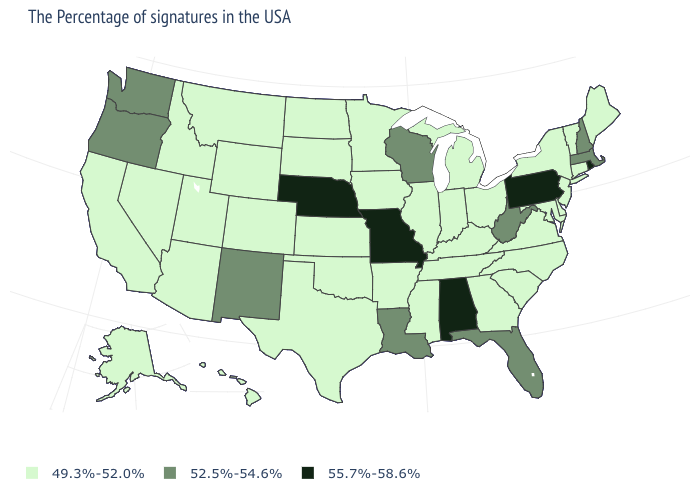Among the states that border Georgia , which have the lowest value?
Concise answer only. North Carolina, South Carolina, Tennessee. Which states have the lowest value in the USA?
Give a very brief answer. Maine, Vermont, Connecticut, New York, New Jersey, Delaware, Maryland, Virginia, North Carolina, South Carolina, Ohio, Georgia, Michigan, Kentucky, Indiana, Tennessee, Illinois, Mississippi, Arkansas, Minnesota, Iowa, Kansas, Oklahoma, Texas, South Dakota, North Dakota, Wyoming, Colorado, Utah, Montana, Arizona, Idaho, Nevada, California, Alaska, Hawaii. Name the states that have a value in the range 49.3%-52.0%?
Keep it brief. Maine, Vermont, Connecticut, New York, New Jersey, Delaware, Maryland, Virginia, North Carolina, South Carolina, Ohio, Georgia, Michigan, Kentucky, Indiana, Tennessee, Illinois, Mississippi, Arkansas, Minnesota, Iowa, Kansas, Oklahoma, Texas, South Dakota, North Dakota, Wyoming, Colorado, Utah, Montana, Arizona, Idaho, Nevada, California, Alaska, Hawaii. Is the legend a continuous bar?
Concise answer only. No. What is the value of Nevada?
Concise answer only. 49.3%-52.0%. Name the states that have a value in the range 55.7%-58.6%?
Keep it brief. Rhode Island, Pennsylvania, Alabama, Missouri, Nebraska. Name the states that have a value in the range 52.5%-54.6%?
Quick response, please. Massachusetts, New Hampshire, West Virginia, Florida, Wisconsin, Louisiana, New Mexico, Washington, Oregon. Name the states that have a value in the range 49.3%-52.0%?
Quick response, please. Maine, Vermont, Connecticut, New York, New Jersey, Delaware, Maryland, Virginia, North Carolina, South Carolina, Ohio, Georgia, Michigan, Kentucky, Indiana, Tennessee, Illinois, Mississippi, Arkansas, Minnesota, Iowa, Kansas, Oklahoma, Texas, South Dakota, North Dakota, Wyoming, Colorado, Utah, Montana, Arizona, Idaho, Nevada, California, Alaska, Hawaii. Among the states that border Maryland , does Pennsylvania have the lowest value?
Write a very short answer. No. Is the legend a continuous bar?
Be succinct. No. Name the states that have a value in the range 55.7%-58.6%?
Quick response, please. Rhode Island, Pennsylvania, Alabama, Missouri, Nebraska. What is the value of Montana?
Give a very brief answer. 49.3%-52.0%. Name the states that have a value in the range 52.5%-54.6%?
Write a very short answer. Massachusetts, New Hampshire, West Virginia, Florida, Wisconsin, Louisiana, New Mexico, Washington, Oregon. Is the legend a continuous bar?
Short answer required. No. 